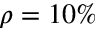<formula> <loc_0><loc_0><loc_500><loc_500>\rho = 1 0 \%</formula> 